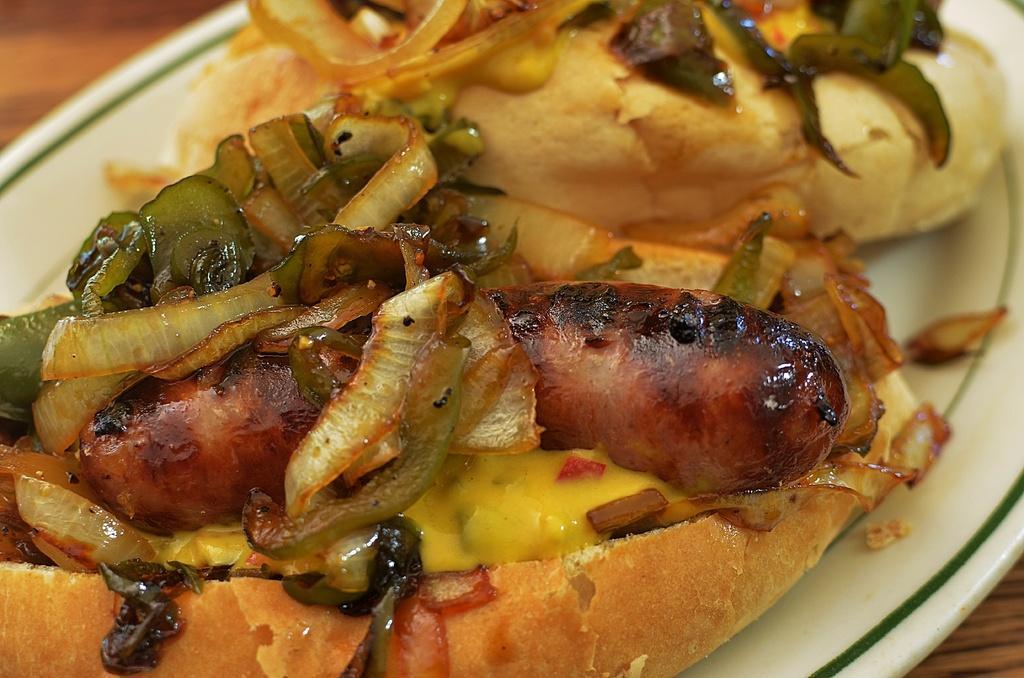How would you summarize this image in a sentence or two? In this image we can see food in plate placed on the table. 